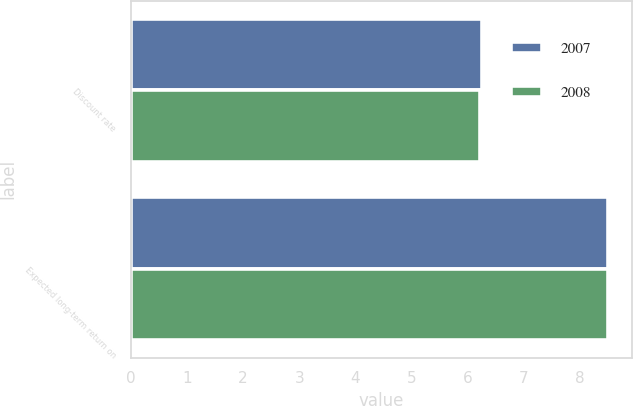Convert chart. <chart><loc_0><loc_0><loc_500><loc_500><stacked_bar_chart><ecel><fcel>Discount rate<fcel>Expected long-term return on<nl><fcel>2007<fcel>6.25<fcel>8.5<nl><fcel>2008<fcel>6.22<fcel>8.5<nl></chart> 